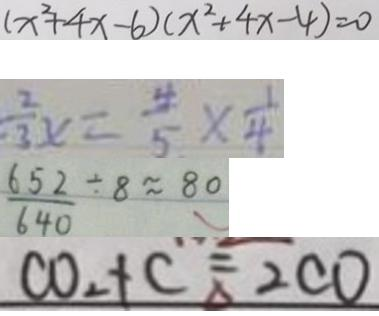Convert formula to latex. <formula><loc_0><loc_0><loc_500><loc_500>( x ^ { 2 } + 4 x - 6 ) ( x ^ { 2 } + 4 x - 4 ) = 0 
 \frac { 2 } { 3 } x = \frac { 4 } { 5 } \times \frac { 1 } { 4 } 
 \frac { 6 5 2 } { 6 4 0 } \div 8 \approx 8 0 
 C O _ { 2 } + C ^ { = } _ { \Delta } 2 C O</formula> 